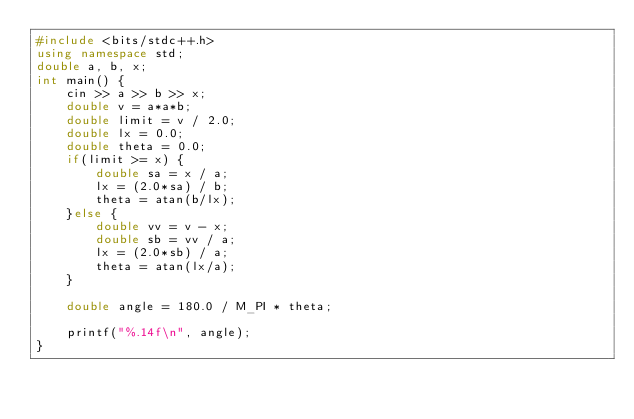Convert code to text. <code><loc_0><loc_0><loc_500><loc_500><_C++_>#include <bits/stdc++.h>
using namespace std;
double a, b, x;
int main() {
    cin >> a >> b >> x;
    double v = a*a*b;
    double limit = v / 2.0;
    double lx = 0.0;
    double theta = 0.0;
    if(limit >= x) {
        double sa = x / a;
        lx = (2.0*sa) / b;
        theta = atan(b/lx);
    }else {
        double vv = v - x;
        double sb = vv / a;
        lx = (2.0*sb) / a;
        theta = atan(lx/a);
    }

    double angle = 180.0 / M_PI * theta;

    printf("%.14f\n", angle);
}</code> 